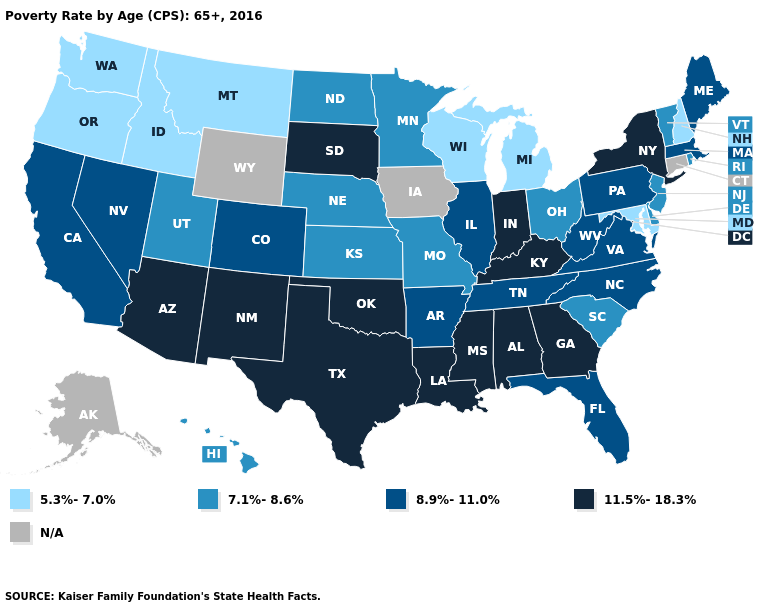Does Vermont have the lowest value in the USA?
Write a very short answer. No. What is the highest value in the USA?
Concise answer only. 11.5%-18.3%. Name the states that have a value in the range 11.5%-18.3%?
Be succinct. Alabama, Arizona, Georgia, Indiana, Kentucky, Louisiana, Mississippi, New Mexico, New York, Oklahoma, South Dakota, Texas. Does Oklahoma have the lowest value in the South?
Concise answer only. No. What is the highest value in states that border Florida?
Write a very short answer. 11.5%-18.3%. Name the states that have a value in the range 8.9%-11.0%?
Concise answer only. Arkansas, California, Colorado, Florida, Illinois, Maine, Massachusetts, Nevada, North Carolina, Pennsylvania, Tennessee, Virginia, West Virginia. What is the value of North Dakota?
Write a very short answer. 7.1%-8.6%. What is the lowest value in states that border South Carolina?
Keep it brief. 8.9%-11.0%. Among the states that border Massachusetts , which have the highest value?
Keep it brief. New York. Among the states that border Kentucky , does Missouri have the highest value?
Be succinct. No. What is the lowest value in the USA?
Write a very short answer. 5.3%-7.0%. What is the value of Nebraska?
Concise answer only. 7.1%-8.6%. What is the lowest value in the USA?
Write a very short answer. 5.3%-7.0%. 